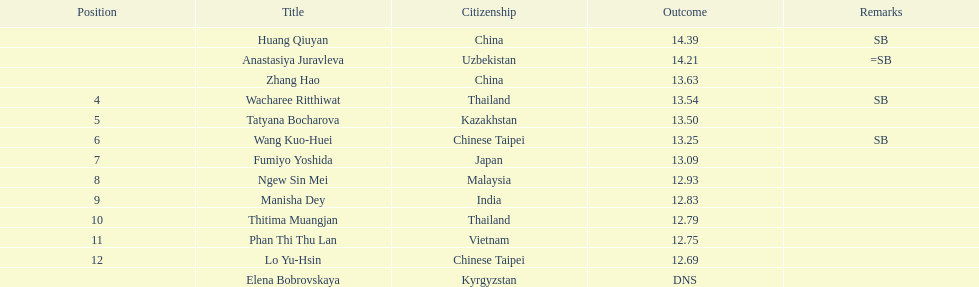How many athletes had a better result than tatyana bocharova? 4. 